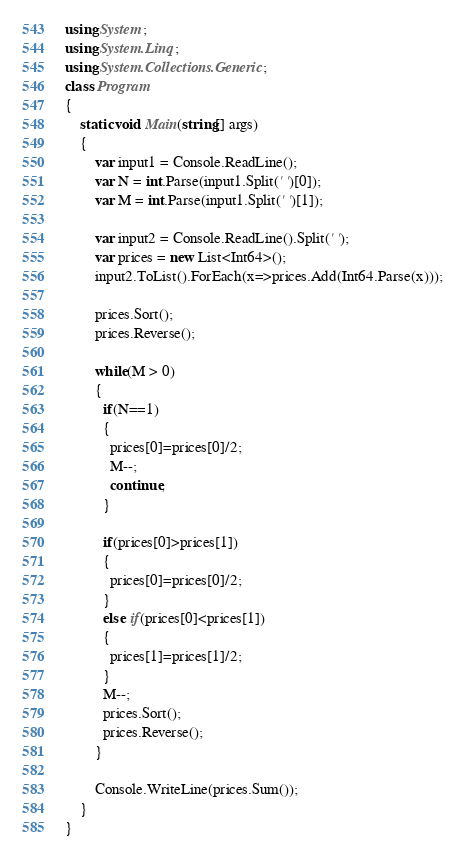Convert code to text. <code><loc_0><loc_0><loc_500><loc_500><_C#_>using System;
using System.Linq;
using System.Collections.Generic;
class Program
{
	static void Main(string[] args)
	{      
        var input1 = Console.ReadLine();
        var N = int.Parse(input1.Split(' ')[0]);
        var M = int.Parse(input1.Split(' ')[1]);
       
        var input2 = Console.ReadLine().Split(' ');
        var prices = new List<Int64>();
        input2.ToList().ForEach(x=>prices.Add(Int64.Parse(x)));
 
        prices.Sort();
        prices.Reverse();
 
      	while(M > 0)
        {
          if(N==1)
          {
            prices[0]=prices[0]/2;
            M--;
            continue;
          }
          
          if(prices[0]>prices[1])
          {
            prices[0]=prices[0]/2;           
          }
          else if(prices[0]<prices[1])
          {
            prices[1]=prices[1]/2;
          }
          M--;
          prices.Sort();
          prices.Reverse();          
        }
      
     	Console.WriteLine(prices.Sum());
	}
}</code> 